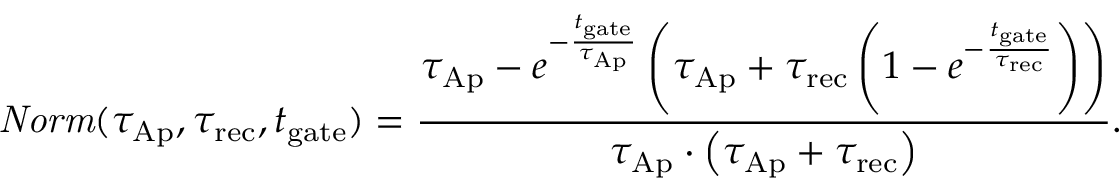<formula> <loc_0><loc_0><loc_500><loc_500>N o r m ( \tau _ { A p } , \tau _ { r e c } , t _ { g a t e } ) = \frac { \tau _ { A p } - e ^ { - \frac { t _ { g a t e } } { \tau _ { A p } } } \left ( \tau _ { A p } + \tau _ { r e c } \left ( 1 - e ^ { - \frac { t _ { g a t e } } { \tau _ { r e c } } } \right ) \right ) } { \tau _ { A p } \cdot \left ( \tau _ { A p } + \tau _ { r e c } \right ) } .</formula> 